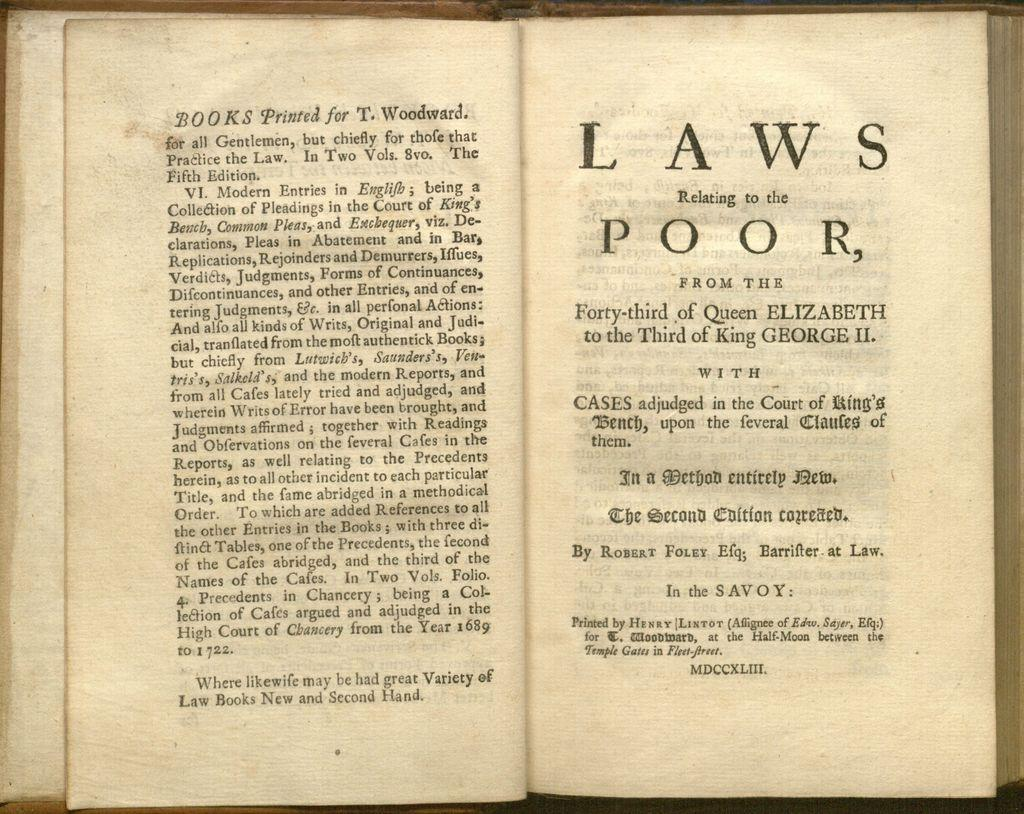<image>
Relay a brief, clear account of the picture shown. Open book with the title "Laws Relationg to the Poor". 